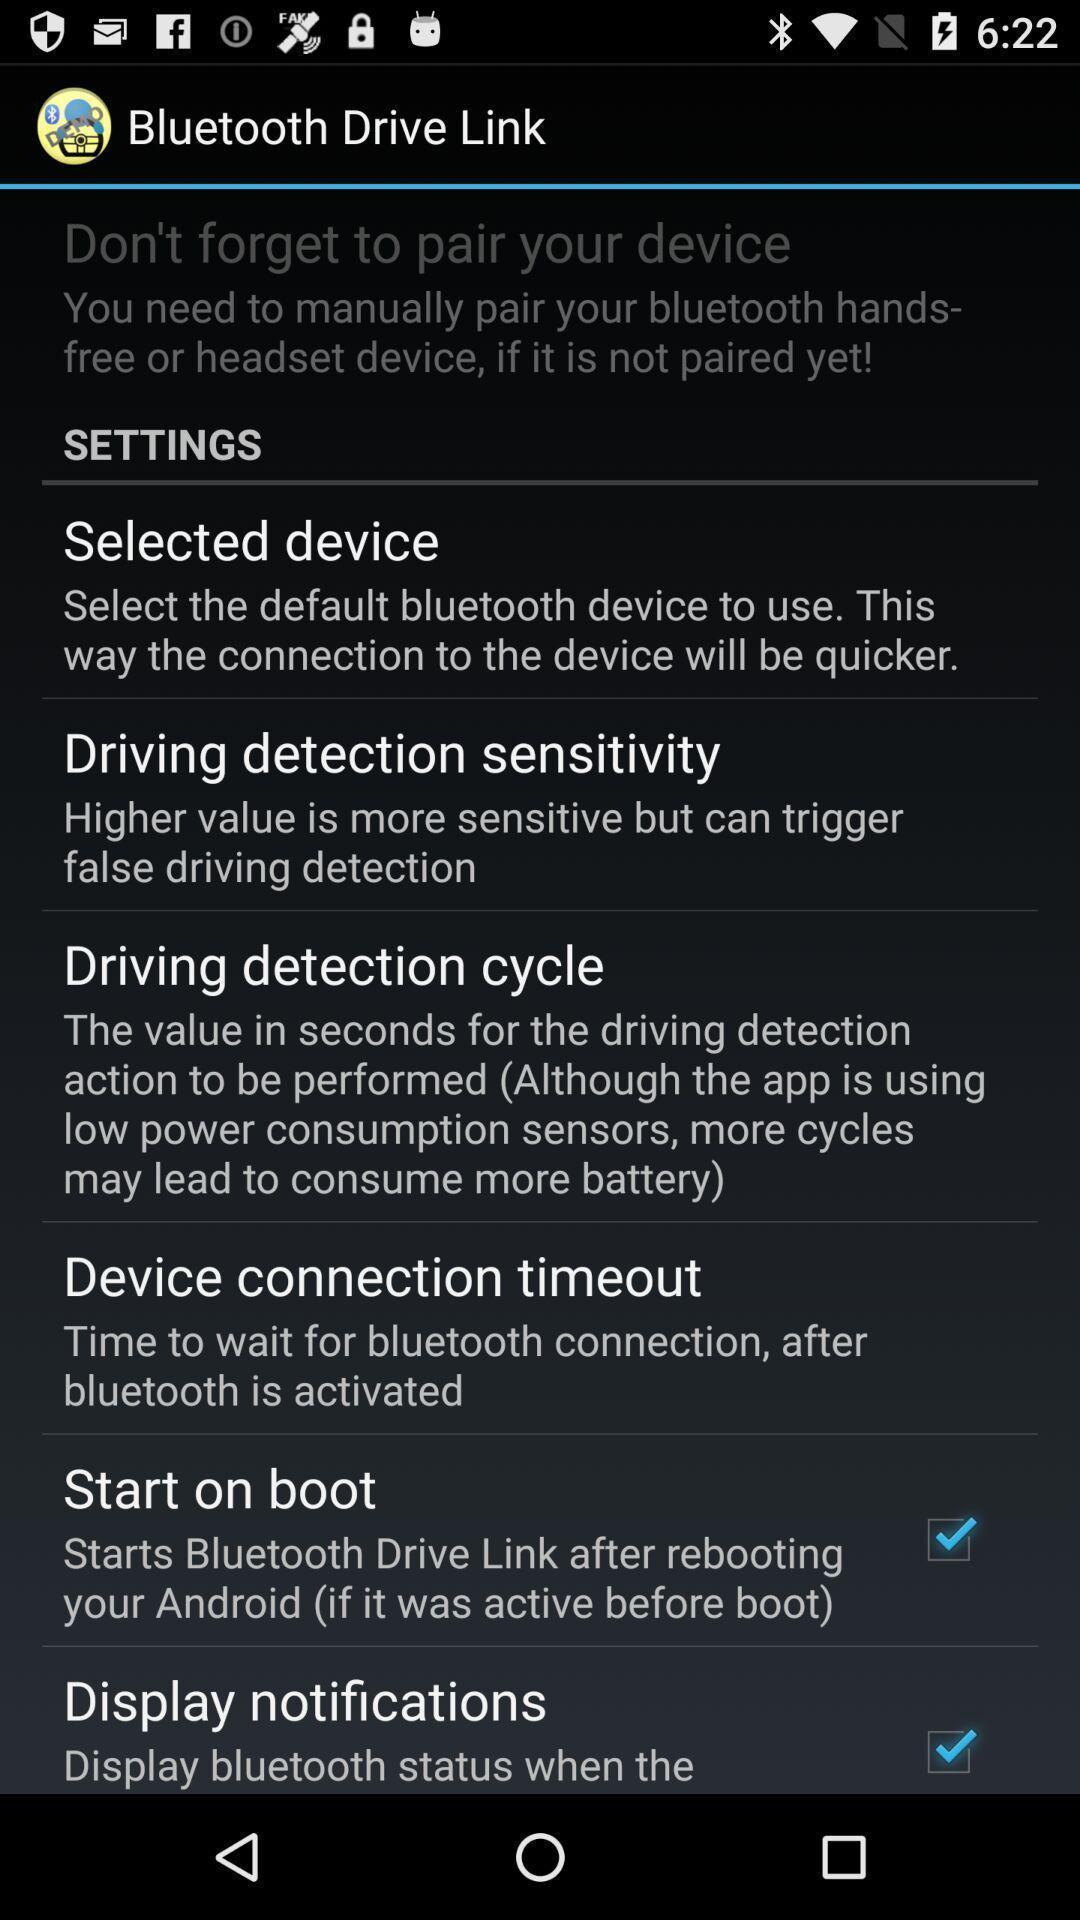What is the overall content of this screenshot? Screen showing settings options. 